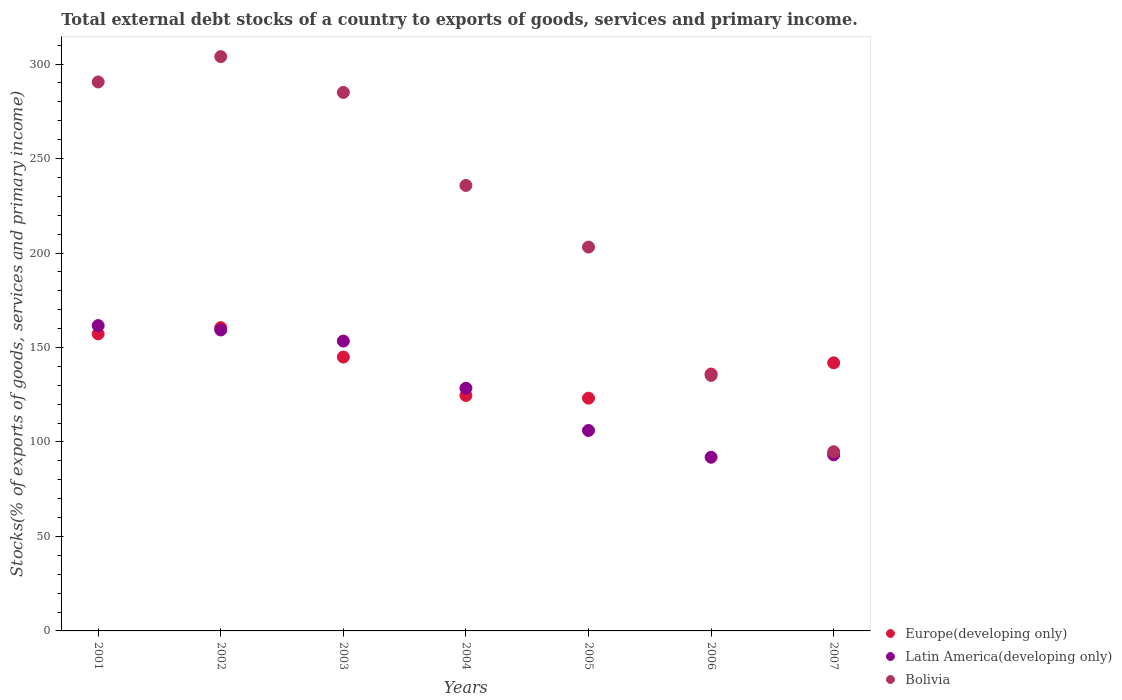Is the number of dotlines equal to the number of legend labels?
Give a very brief answer. Yes. What is the total debt stocks in Latin America(developing only) in 2001?
Provide a short and direct response. 161.59. Across all years, what is the maximum total debt stocks in Latin America(developing only)?
Offer a terse response. 161.59. Across all years, what is the minimum total debt stocks in Europe(developing only)?
Your response must be concise. 123.19. What is the total total debt stocks in Latin America(developing only) in the graph?
Provide a short and direct response. 893.89. What is the difference between the total debt stocks in Latin America(developing only) in 2004 and that in 2006?
Your response must be concise. 36.52. What is the difference between the total debt stocks in Latin America(developing only) in 2003 and the total debt stocks in Europe(developing only) in 2001?
Your answer should be very brief. -3.82. What is the average total debt stocks in Latin America(developing only) per year?
Provide a succinct answer. 127.7. In the year 2004, what is the difference between the total debt stocks in Bolivia and total debt stocks in Latin America(developing only)?
Provide a short and direct response. 107.32. What is the ratio of the total debt stocks in Europe(developing only) in 2005 to that in 2006?
Offer a very short reply. 0.91. Is the difference between the total debt stocks in Bolivia in 2003 and 2007 greater than the difference between the total debt stocks in Latin America(developing only) in 2003 and 2007?
Ensure brevity in your answer.  Yes. What is the difference between the highest and the second highest total debt stocks in Europe(developing only)?
Make the answer very short. 3.29. What is the difference between the highest and the lowest total debt stocks in Latin America(developing only)?
Offer a terse response. 69.67. Is it the case that in every year, the sum of the total debt stocks in Bolivia and total debt stocks in Latin America(developing only)  is greater than the total debt stocks in Europe(developing only)?
Keep it short and to the point. Yes. Is the total debt stocks in Bolivia strictly less than the total debt stocks in Latin America(developing only) over the years?
Provide a succinct answer. No. How many dotlines are there?
Provide a succinct answer. 3. How many years are there in the graph?
Ensure brevity in your answer.  7. Are the values on the major ticks of Y-axis written in scientific E-notation?
Offer a terse response. No. Does the graph contain any zero values?
Your response must be concise. No. What is the title of the graph?
Offer a terse response. Total external debt stocks of a country to exports of goods, services and primary income. What is the label or title of the Y-axis?
Your answer should be compact. Stocks(% of exports of goods, services and primary income). What is the Stocks(% of exports of goods, services and primary income) in Europe(developing only) in 2001?
Provide a short and direct response. 157.22. What is the Stocks(% of exports of goods, services and primary income) of Latin America(developing only) in 2001?
Provide a short and direct response. 161.59. What is the Stocks(% of exports of goods, services and primary income) in Bolivia in 2001?
Offer a terse response. 290.53. What is the Stocks(% of exports of goods, services and primary income) in Europe(developing only) in 2002?
Your answer should be very brief. 160.51. What is the Stocks(% of exports of goods, services and primary income) of Latin America(developing only) in 2002?
Keep it short and to the point. 159.27. What is the Stocks(% of exports of goods, services and primary income) of Bolivia in 2002?
Ensure brevity in your answer.  303.95. What is the Stocks(% of exports of goods, services and primary income) in Europe(developing only) in 2003?
Your answer should be very brief. 144.95. What is the Stocks(% of exports of goods, services and primary income) of Latin America(developing only) in 2003?
Offer a very short reply. 153.4. What is the Stocks(% of exports of goods, services and primary income) in Bolivia in 2003?
Your answer should be very brief. 284.99. What is the Stocks(% of exports of goods, services and primary income) of Europe(developing only) in 2004?
Give a very brief answer. 124.59. What is the Stocks(% of exports of goods, services and primary income) of Latin America(developing only) in 2004?
Make the answer very short. 128.44. What is the Stocks(% of exports of goods, services and primary income) of Bolivia in 2004?
Keep it short and to the point. 235.76. What is the Stocks(% of exports of goods, services and primary income) in Europe(developing only) in 2005?
Your answer should be very brief. 123.19. What is the Stocks(% of exports of goods, services and primary income) in Latin America(developing only) in 2005?
Give a very brief answer. 106.09. What is the Stocks(% of exports of goods, services and primary income) of Bolivia in 2005?
Keep it short and to the point. 203.15. What is the Stocks(% of exports of goods, services and primary income) of Europe(developing only) in 2006?
Make the answer very short. 135.96. What is the Stocks(% of exports of goods, services and primary income) in Latin America(developing only) in 2006?
Offer a very short reply. 91.92. What is the Stocks(% of exports of goods, services and primary income) of Bolivia in 2006?
Make the answer very short. 135.23. What is the Stocks(% of exports of goods, services and primary income) of Europe(developing only) in 2007?
Offer a very short reply. 141.88. What is the Stocks(% of exports of goods, services and primary income) of Latin America(developing only) in 2007?
Offer a terse response. 93.18. What is the Stocks(% of exports of goods, services and primary income) in Bolivia in 2007?
Provide a short and direct response. 94.83. Across all years, what is the maximum Stocks(% of exports of goods, services and primary income) in Europe(developing only)?
Keep it short and to the point. 160.51. Across all years, what is the maximum Stocks(% of exports of goods, services and primary income) in Latin America(developing only)?
Offer a very short reply. 161.59. Across all years, what is the maximum Stocks(% of exports of goods, services and primary income) of Bolivia?
Provide a short and direct response. 303.95. Across all years, what is the minimum Stocks(% of exports of goods, services and primary income) in Europe(developing only)?
Provide a succinct answer. 123.19. Across all years, what is the minimum Stocks(% of exports of goods, services and primary income) of Latin America(developing only)?
Ensure brevity in your answer.  91.92. Across all years, what is the minimum Stocks(% of exports of goods, services and primary income) in Bolivia?
Make the answer very short. 94.83. What is the total Stocks(% of exports of goods, services and primary income) in Europe(developing only) in the graph?
Keep it short and to the point. 988.29. What is the total Stocks(% of exports of goods, services and primary income) of Latin America(developing only) in the graph?
Your response must be concise. 893.89. What is the total Stocks(% of exports of goods, services and primary income) of Bolivia in the graph?
Your response must be concise. 1548.45. What is the difference between the Stocks(% of exports of goods, services and primary income) of Europe(developing only) in 2001 and that in 2002?
Ensure brevity in your answer.  -3.29. What is the difference between the Stocks(% of exports of goods, services and primary income) of Latin America(developing only) in 2001 and that in 2002?
Your response must be concise. 2.32. What is the difference between the Stocks(% of exports of goods, services and primary income) of Bolivia in 2001 and that in 2002?
Ensure brevity in your answer.  -13.42. What is the difference between the Stocks(% of exports of goods, services and primary income) in Europe(developing only) in 2001 and that in 2003?
Provide a short and direct response. 12.27. What is the difference between the Stocks(% of exports of goods, services and primary income) in Latin America(developing only) in 2001 and that in 2003?
Make the answer very short. 8.2. What is the difference between the Stocks(% of exports of goods, services and primary income) of Bolivia in 2001 and that in 2003?
Ensure brevity in your answer.  5.54. What is the difference between the Stocks(% of exports of goods, services and primary income) of Europe(developing only) in 2001 and that in 2004?
Your response must be concise. 32.63. What is the difference between the Stocks(% of exports of goods, services and primary income) of Latin America(developing only) in 2001 and that in 2004?
Offer a terse response. 33.15. What is the difference between the Stocks(% of exports of goods, services and primary income) of Bolivia in 2001 and that in 2004?
Provide a succinct answer. 54.77. What is the difference between the Stocks(% of exports of goods, services and primary income) of Europe(developing only) in 2001 and that in 2005?
Give a very brief answer. 34.03. What is the difference between the Stocks(% of exports of goods, services and primary income) in Latin America(developing only) in 2001 and that in 2005?
Your answer should be very brief. 55.5. What is the difference between the Stocks(% of exports of goods, services and primary income) of Bolivia in 2001 and that in 2005?
Your answer should be compact. 87.38. What is the difference between the Stocks(% of exports of goods, services and primary income) of Europe(developing only) in 2001 and that in 2006?
Provide a succinct answer. 21.26. What is the difference between the Stocks(% of exports of goods, services and primary income) of Latin America(developing only) in 2001 and that in 2006?
Offer a very short reply. 69.67. What is the difference between the Stocks(% of exports of goods, services and primary income) of Bolivia in 2001 and that in 2006?
Ensure brevity in your answer.  155.3. What is the difference between the Stocks(% of exports of goods, services and primary income) of Europe(developing only) in 2001 and that in 2007?
Give a very brief answer. 15.34. What is the difference between the Stocks(% of exports of goods, services and primary income) in Latin America(developing only) in 2001 and that in 2007?
Provide a succinct answer. 68.41. What is the difference between the Stocks(% of exports of goods, services and primary income) of Bolivia in 2001 and that in 2007?
Offer a terse response. 195.7. What is the difference between the Stocks(% of exports of goods, services and primary income) of Europe(developing only) in 2002 and that in 2003?
Provide a short and direct response. 15.55. What is the difference between the Stocks(% of exports of goods, services and primary income) in Latin America(developing only) in 2002 and that in 2003?
Your answer should be very brief. 5.87. What is the difference between the Stocks(% of exports of goods, services and primary income) in Bolivia in 2002 and that in 2003?
Your answer should be very brief. 18.95. What is the difference between the Stocks(% of exports of goods, services and primary income) in Europe(developing only) in 2002 and that in 2004?
Ensure brevity in your answer.  35.92. What is the difference between the Stocks(% of exports of goods, services and primary income) of Latin America(developing only) in 2002 and that in 2004?
Provide a succinct answer. 30.83. What is the difference between the Stocks(% of exports of goods, services and primary income) in Bolivia in 2002 and that in 2004?
Give a very brief answer. 68.19. What is the difference between the Stocks(% of exports of goods, services and primary income) in Europe(developing only) in 2002 and that in 2005?
Provide a short and direct response. 37.32. What is the difference between the Stocks(% of exports of goods, services and primary income) in Latin America(developing only) in 2002 and that in 2005?
Ensure brevity in your answer.  53.18. What is the difference between the Stocks(% of exports of goods, services and primary income) in Bolivia in 2002 and that in 2005?
Make the answer very short. 100.8. What is the difference between the Stocks(% of exports of goods, services and primary income) of Europe(developing only) in 2002 and that in 2006?
Provide a short and direct response. 24.55. What is the difference between the Stocks(% of exports of goods, services and primary income) in Latin America(developing only) in 2002 and that in 2006?
Provide a succinct answer. 67.35. What is the difference between the Stocks(% of exports of goods, services and primary income) of Bolivia in 2002 and that in 2006?
Your answer should be compact. 168.71. What is the difference between the Stocks(% of exports of goods, services and primary income) of Europe(developing only) in 2002 and that in 2007?
Provide a short and direct response. 18.62. What is the difference between the Stocks(% of exports of goods, services and primary income) of Latin America(developing only) in 2002 and that in 2007?
Offer a very short reply. 66.09. What is the difference between the Stocks(% of exports of goods, services and primary income) in Bolivia in 2002 and that in 2007?
Your answer should be very brief. 209.12. What is the difference between the Stocks(% of exports of goods, services and primary income) of Europe(developing only) in 2003 and that in 2004?
Your answer should be very brief. 20.36. What is the difference between the Stocks(% of exports of goods, services and primary income) of Latin America(developing only) in 2003 and that in 2004?
Your answer should be very brief. 24.96. What is the difference between the Stocks(% of exports of goods, services and primary income) of Bolivia in 2003 and that in 2004?
Provide a short and direct response. 49.23. What is the difference between the Stocks(% of exports of goods, services and primary income) of Europe(developing only) in 2003 and that in 2005?
Ensure brevity in your answer.  21.76. What is the difference between the Stocks(% of exports of goods, services and primary income) of Latin America(developing only) in 2003 and that in 2005?
Your answer should be compact. 47.31. What is the difference between the Stocks(% of exports of goods, services and primary income) in Bolivia in 2003 and that in 2005?
Ensure brevity in your answer.  81.84. What is the difference between the Stocks(% of exports of goods, services and primary income) in Europe(developing only) in 2003 and that in 2006?
Ensure brevity in your answer.  9. What is the difference between the Stocks(% of exports of goods, services and primary income) in Latin America(developing only) in 2003 and that in 2006?
Make the answer very short. 61.48. What is the difference between the Stocks(% of exports of goods, services and primary income) of Bolivia in 2003 and that in 2006?
Offer a very short reply. 149.76. What is the difference between the Stocks(% of exports of goods, services and primary income) in Europe(developing only) in 2003 and that in 2007?
Your answer should be very brief. 3.07. What is the difference between the Stocks(% of exports of goods, services and primary income) in Latin America(developing only) in 2003 and that in 2007?
Offer a terse response. 60.22. What is the difference between the Stocks(% of exports of goods, services and primary income) in Bolivia in 2003 and that in 2007?
Make the answer very short. 190.16. What is the difference between the Stocks(% of exports of goods, services and primary income) of Europe(developing only) in 2004 and that in 2005?
Offer a very short reply. 1.4. What is the difference between the Stocks(% of exports of goods, services and primary income) of Latin America(developing only) in 2004 and that in 2005?
Offer a very short reply. 22.35. What is the difference between the Stocks(% of exports of goods, services and primary income) of Bolivia in 2004 and that in 2005?
Keep it short and to the point. 32.61. What is the difference between the Stocks(% of exports of goods, services and primary income) of Europe(developing only) in 2004 and that in 2006?
Provide a short and direct response. -11.37. What is the difference between the Stocks(% of exports of goods, services and primary income) in Latin America(developing only) in 2004 and that in 2006?
Give a very brief answer. 36.52. What is the difference between the Stocks(% of exports of goods, services and primary income) in Bolivia in 2004 and that in 2006?
Your answer should be compact. 100.52. What is the difference between the Stocks(% of exports of goods, services and primary income) of Europe(developing only) in 2004 and that in 2007?
Ensure brevity in your answer.  -17.29. What is the difference between the Stocks(% of exports of goods, services and primary income) of Latin America(developing only) in 2004 and that in 2007?
Provide a short and direct response. 35.26. What is the difference between the Stocks(% of exports of goods, services and primary income) in Bolivia in 2004 and that in 2007?
Keep it short and to the point. 140.93. What is the difference between the Stocks(% of exports of goods, services and primary income) in Europe(developing only) in 2005 and that in 2006?
Ensure brevity in your answer.  -12.77. What is the difference between the Stocks(% of exports of goods, services and primary income) of Latin America(developing only) in 2005 and that in 2006?
Your response must be concise. 14.17. What is the difference between the Stocks(% of exports of goods, services and primary income) in Bolivia in 2005 and that in 2006?
Offer a very short reply. 67.92. What is the difference between the Stocks(% of exports of goods, services and primary income) of Europe(developing only) in 2005 and that in 2007?
Keep it short and to the point. -18.7. What is the difference between the Stocks(% of exports of goods, services and primary income) in Latin America(developing only) in 2005 and that in 2007?
Give a very brief answer. 12.91. What is the difference between the Stocks(% of exports of goods, services and primary income) in Bolivia in 2005 and that in 2007?
Provide a short and direct response. 108.32. What is the difference between the Stocks(% of exports of goods, services and primary income) of Europe(developing only) in 2006 and that in 2007?
Offer a terse response. -5.93. What is the difference between the Stocks(% of exports of goods, services and primary income) in Latin America(developing only) in 2006 and that in 2007?
Ensure brevity in your answer.  -1.26. What is the difference between the Stocks(% of exports of goods, services and primary income) of Bolivia in 2006 and that in 2007?
Offer a terse response. 40.4. What is the difference between the Stocks(% of exports of goods, services and primary income) in Europe(developing only) in 2001 and the Stocks(% of exports of goods, services and primary income) in Latin America(developing only) in 2002?
Give a very brief answer. -2.05. What is the difference between the Stocks(% of exports of goods, services and primary income) in Europe(developing only) in 2001 and the Stocks(% of exports of goods, services and primary income) in Bolivia in 2002?
Provide a succinct answer. -146.73. What is the difference between the Stocks(% of exports of goods, services and primary income) of Latin America(developing only) in 2001 and the Stocks(% of exports of goods, services and primary income) of Bolivia in 2002?
Ensure brevity in your answer.  -142.35. What is the difference between the Stocks(% of exports of goods, services and primary income) in Europe(developing only) in 2001 and the Stocks(% of exports of goods, services and primary income) in Latin America(developing only) in 2003?
Give a very brief answer. 3.82. What is the difference between the Stocks(% of exports of goods, services and primary income) of Europe(developing only) in 2001 and the Stocks(% of exports of goods, services and primary income) of Bolivia in 2003?
Your response must be concise. -127.78. What is the difference between the Stocks(% of exports of goods, services and primary income) of Latin America(developing only) in 2001 and the Stocks(% of exports of goods, services and primary income) of Bolivia in 2003?
Provide a succinct answer. -123.4. What is the difference between the Stocks(% of exports of goods, services and primary income) in Europe(developing only) in 2001 and the Stocks(% of exports of goods, services and primary income) in Latin America(developing only) in 2004?
Offer a terse response. 28.78. What is the difference between the Stocks(% of exports of goods, services and primary income) in Europe(developing only) in 2001 and the Stocks(% of exports of goods, services and primary income) in Bolivia in 2004?
Your answer should be compact. -78.54. What is the difference between the Stocks(% of exports of goods, services and primary income) of Latin America(developing only) in 2001 and the Stocks(% of exports of goods, services and primary income) of Bolivia in 2004?
Give a very brief answer. -74.17. What is the difference between the Stocks(% of exports of goods, services and primary income) in Europe(developing only) in 2001 and the Stocks(% of exports of goods, services and primary income) in Latin America(developing only) in 2005?
Keep it short and to the point. 51.13. What is the difference between the Stocks(% of exports of goods, services and primary income) in Europe(developing only) in 2001 and the Stocks(% of exports of goods, services and primary income) in Bolivia in 2005?
Ensure brevity in your answer.  -45.93. What is the difference between the Stocks(% of exports of goods, services and primary income) in Latin America(developing only) in 2001 and the Stocks(% of exports of goods, services and primary income) in Bolivia in 2005?
Provide a succinct answer. -41.56. What is the difference between the Stocks(% of exports of goods, services and primary income) of Europe(developing only) in 2001 and the Stocks(% of exports of goods, services and primary income) of Latin America(developing only) in 2006?
Your answer should be very brief. 65.3. What is the difference between the Stocks(% of exports of goods, services and primary income) in Europe(developing only) in 2001 and the Stocks(% of exports of goods, services and primary income) in Bolivia in 2006?
Provide a succinct answer. 21.98. What is the difference between the Stocks(% of exports of goods, services and primary income) of Latin America(developing only) in 2001 and the Stocks(% of exports of goods, services and primary income) of Bolivia in 2006?
Ensure brevity in your answer.  26.36. What is the difference between the Stocks(% of exports of goods, services and primary income) of Europe(developing only) in 2001 and the Stocks(% of exports of goods, services and primary income) of Latin America(developing only) in 2007?
Provide a succinct answer. 64.04. What is the difference between the Stocks(% of exports of goods, services and primary income) in Europe(developing only) in 2001 and the Stocks(% of exports of goods, services and primary income) in Bolivia in 2007?
Offer a terse response. 62.39. What is the difference between the Stocks(% of exports of goods, services and primary income) in Latin America(developing only) in 2001 and the Stocks(% of exports of goods, services and primary income) in Bolivia in 2007?
Your answer should be compact. 66.76. What is the difference between the Stocks(% of exports of goods, services and primary income) in Europe(developing only) in 2002 and the Stocks(% of exports of goods, services and primary income) in Latin America(developing only) in 2003?
Keep it short and to the point. 7.11. What is the difference between the Stocks(% of exports of goods, services and primary income) in Europe(developing only) in 2002 and the Stocks(% of exports of goods, services and primary income) in Bolivia in 2003?
Ensure brevity in your answer.  -124.49. What is the difference between the Stocks(% of exports of goods, services and primary income) in Latin America(developing only) in 2002 and the Stocks(% of exports of goods, services and primary income) in Bolivia in 2003?
Your answer should be compact. -125.72. What is the difference between the Stocks(% of exports of goods, services and primary income) in Europe(developing only) in 2002 and the Stocks(% of exports of goods, services and primary income) in Latin America(developing only) in 2004?
Give a very brief answer. 32.06. What is the difference between the Stocks(% of exports of goods, services and primary income) in Europe(developing only) in 2002 and the Stocks(% of exports of goods, services and primary income) in Bolivia in 2004?
Your answer should be very brief. -75.25. What is the difference between the Stocks(% of exports of goods, services and primary income) in Latin America(developing only) in 2002 and the Stocks(% of exports of goods, services and primary income) in Bolivia in 2004?
Keep it short and to the point. -76.49. What is the difference between the Stocks(% of exports of goods, services and primary income) of Europe(developing only) in 2002 and the Stocks(% of exports of goods, services and primary income) of Latin America(developing only) in 2005?
Offer a very short reply. 54.42. What is the difference between the Stocks(% of exports of goods, services and primary income) of Europe(developing only) in 2002 and the Stocks(% of exports of goods, services and primary income) of Bolivia in 2005?
Offer a very short reply. -42.64. What is the difference between the Stocks(% of exports of goods, services and primary income) of Latin America(developing only) in 2002 and the Stocks(% of exports of goods, services and primary income) of Bolivia in 2005?
Make the answer very short. -43.88. What is the difference between the Stocks(% of exports of goods, services and primary income) in Europe(developing only) in 2002 and the Stocks(% of exports of goods, services and primary income) in Latin America(developing only) in 2006?
Keep it short and to the point. 68.59. What is the difference between the Stocks(% of exports of goods, services and primary income) of Europe(developing only) in 2002 and the Stocks(% of exports of goods, services and primary income) of Bolivia in 2006?
Give a very brief answer. 25.27. What is the difference between the Stocks(% of exports of goods, services and primary income) of Latin America(developing only) in 2002 and the Stocks(% of exports of goods, services and primary income) of Bolivia in 2006?
Your answer should be very brief. 24.04. What is the difference between the Stocks(% of exports of goods, services and primary income) in Europe(developing only) in 2002 and the Stocks(% of exports of goods, services and primary income) in Latin America(developing only) in 2007?
Offer a very short reply. 67.33. What is the difference between the Stocks(% of exports of goods, services and primary income) of Europe(developing only) in 2002 and the Stocks(% of exports of goods, services and primary income) of Bolivia in 2007?
Offer a very short reply. 65.67. What is the difference between the Stocks(% of exports of goods, services and primary income) in Latin America(developing only) in 2002 and the Stocks(% of exports of goods, services and primary income) in Bolivia in 2007?
Provide a succinct answer. 64.44. What is the difference between the Stocks(% of exports of goods, services and primary income) of Europe(developing only) in 2003 and the Stocks(% of exports of goods, services and primary income) of Latin America(developing only) in 2004?
Offer a very short reply. 16.51. What is the difference between the Stocks(% of exports of goods, services and primary income) of Europe(developing only) in 2003 and the Stocks(% of exports of goods, services and primary income) of Bolivia in 2004?
Offer a very short reply. -90.81. What is the difference between the Stocks(% of exports of goods, services and primary income) in Latin America(developing only) in 2003 and the Stocks(% of exports of goods, services and primary income) in Bolivia in 2004?
Ensure brevity in your answer.  -82.36. What is the difference between the Stocks(% of exports of goods, services and primary income) of Europe(developing only) in 2003 and the Stocks(% of exports of goods, services and primary income) of Latin America(developing only) in 2005?
Offer a terse response. 38.86. What is the difference between the Stocks(% of exports of goods, services and primary income) in Europe(developing only) in 2003 and the Stocks(% of exports of goods, services and primary income) in Bolivia in 2005?
Make the answer very short. -58.2. What is the difference between the Stocks(% of exports of goods, services and primary income) of Latin America(developing only) in 2003 and the Stocks(% of exports of goods, services and primary income) of Bolivia in 2005?
Offer a terse response. -49.75. What is the difference between the Stocks(% of exports of goods, services and primary income) of Europe(developing only) in 2003 and the Stocks(% of exports of goods, services and primary income) of Latin America(developing only) in 2006?
Provide a succinct answer. 53.03. What is the difference between the Stocks(% of exports of goods, services and primary income) of Europe(developing only) in 2003 and the Stocks(% of exports of goods, services and primary income) of Bolivia in 2006?
Keep it short and to the point. 9.72. What is the difference between the Stocks(% of exports of goods, services and primary income) in Latin America(developing only) in 2003 and the Stocks(% of exports of goods, services and primary income) in Bolivia in 2006?
Your answer should be compact. 18.16. What is the difference between the Stocks(% of exports of goods, services and primary income) in Europe(developing only) in 2003 and the Stocks(% of exports of goods, services and primary income) in Latin America(developing only) in 2007?
Your answer should be compact. 51.77. What is the difference between the Stocks(% of exports of goods, services and primary income) in Europe(developing only) in 2003 and the Stocks(% of exports of goods, services and primary income) in Bolivia in 2007?
Your answer should be compact. 50.12. What is the difference between the Stocks(% of exports of goods, services and primary income) of Latin America(developing only) in 2003 and the Stocks(% of exports of goods, services and primary income) of Bolivia in 2007?
Provide a short and direct response. 58.56. What is the difference between the Stocks(% of exports of goods, services and primary income) of Europe(developing only) in 2004 and the Stocks(% of exports of goods, services and primary income) of Latin America(developing only) in 2005?
Give a very brief answer. 18.5. What is the difference between the Stocks(% of exports of goods, services and primary income) of Europe(developing only) in 2004 and the Stocks(% of exports of goods, services and primary income) of Bolivia in 2005?
Provide a succinct answer. -78.56. What is the difference between the Stocks(% of exports of goods, services and primary income) of Latin America(developing only) in 2004 and the Stocks(% of exports of goods, services and primary income) of Bolivia in 2005?
Your response must be concise. -74.71. What is the difference between the Stocks(% of exports of goods, services and primary income) of Europe(developing only) in 2004 and the Stocks(% of exports of goods, services and primary income) of Latin America(developing only) in 2006?
Offer a very short reply. 32.67. What is the difference between the Stocks(% of exports of goods, services and primary income) of Europe(developing only) in 2004 and the Stocks(% of exports of goods, services and primary income) of Bolivia in 2006?
Your answer should be very brief. -10.65. What is the difference between the Stocks(% of exports of goods, services and primary income) in Latin America(developing only) in 2004 and the Stocks(% of exports of goods, services and primary income) in Bolivia in 2006?
Your answer should be very brief. -6.79. What is the difference between the Stocks(% of exports of goods, services and primary income) in Europe(developing only) in 2004 and the Stocks(% of exports of goods, services and primary income) in Latin America(developing only) in 2007?
Your answer should be compact. 31.41. What is the difference between the Stocks(% of exports of goods, services and primary income) of Europe(developing only) in 2004 and the Stocks(% of exports of goods, services and primary income) of Bolivia in 2007?
Provide a succinct answer. 29.76. What is the difference between the Stocks(% of exports of goods, services and primary income) in Latin America(developing only) in 2004 and the Stocks(% of exports of goods, services and primary income) in Bolivia in 2007?
Offer a very short reply. 33.61. What is the difference between the Stocks(% of exports of goods, services and primary income) of Europe(developing only) in 2005 and the Stocks(% of exports of goods, services and primary income) of Latin America(developing only) in 2006?
Provide a succinct answer. 31.27. What is the difference between the Stocks(% of exports of goods, services and primary income) in Europe(developing only) in 2005 and the Stocks(% of exports of goods, services and primary income) in Bolivia in 2006?
Offer a terse response. -12.05. What is the difference between the Stocks(% of exports of goods, services and primary income) of Latin America(developing only) in 2005 and the Stocks(% of exports of goods, services and primary income) of Bolivia in 2006?
Your answer should be very brief. -29.14. What is the difference between the Stocks(% of exports of goods, services and primary income) of Europe(developing only) in 2005 and the Stocks(% of exports of goods, services and primary income) of Latin America(developing only) in 2007?
Offer a terse response. 30.01. What is the difference between the Stocks(% of exports of goods, services and primary income) of Europe(developing only) in 2005 and the Stocks(% of exports of goods, services and primary income) of Bolivia in 2007?
Give a very brief answer. 28.35. What is the difference between the Stocks(% of exports of goods, services and primary income) in Latin America(developing only) in 2005 and the Stocks(% of exports of goods, services and primary income) in Bolivia in 2007?
Offer a terse response. 11.26. What is the difference between the Stocks(% of exports of goods, services and primary income) of Europe(developing only) in 2006 and the Stocks(% of exports of goods, services and primary income) of Latin America(developing only) in 2007?
Your answer should be compact. 42.78. What is the difference between the Stocks(% of exports of goods, services and primary income) in Europe(developing only) in 2006 and the Stocks(% of exports of goods, services and primary income) in Bolivia in 2007?
Make the answer very short. 41.12. What is the difference between the Stocks(% of exports of goods, services and primary income) in Latin America(developing only) in 2006 and the Stocks(% of exports of goods, services and primary income) in Bolivia in 2007?
Your answer should be very brief. -2.91. What is the average Stocks(% of exports of goods, services and primary income) of Europe(developing only) per year?
Your answer should be very brief. 141.18. What is the average Stocks(% of exports of goods, services and primary income) of Latin America(developing only) per year?
Your answer should be very brief. 127.7. What is the average Stocks(% of exports of goods, services and primary income) of Bolivia per year?
Provide a succinct answer. 221.21. In the year 2001, what is the difference between the Stocks(% of exports of goods, services and primary income) of Europe(developing only) and Stocks(% of exports of goods, services and primary income) of Latin America(developing only)?
Your answer should be very brief. -4.38. In the year 2001, what is the difference between the Stocks(% of exports of goods, services and primary income) in Europe(developing only) and Stocks(% of exports of goods, services and primary income) in Bolivia?
Provide a short and direct response. -133.31. In the year 2001, what is the difference between the Stocks(% of exports of goods, services and primary income) of Latin America(developing only) and Stocks(% of exports of goods, services and primary income) of Bolivia?
Keep it short and to the point. -128.94. In the year 2002, what is the difference between the Stocks(% of exports of goods, services and primary income) in Europe(developing only) and Stocks(% of exports of goods, services and primary income) in Latin America(developing only)?
Your answer should be compact. 1.24. In the year 2002, what is the difference between the Stocks(% of exports of goods, services and primary income) in Europe(developing only) and Stocks(% of exports of goods, services and primary income) in Bolivia?
Your answer should be compact. -143.44. In the year 2002, what is the difference between the Stocks(% of exports of goods, services and primary income) in Latin America(developing only) and Stocks(% of exports of goods, services and primary income) in Bolivia?
Make the answer very short. -144.68. In the year 2003, what is the difference between the Stocks(% of exports of goods, services and primary income) in Europe(developing only) and Stocks(% of exports of goods, services and primary income) in Latin America(developing only)?
Your answer should be compact. -8.45. In the year 2003, what is the difference between the Stocks(% of exports of goods, services and primary income) of Europe(developing only) and Stocks(% of exports of goods, services and primary income) of Bolivia?
Your answer should be compact. -140.04. In the year 2003, what is the difference between the Stocks(% of exports of goods, services and primary income) in Latin America(developing only) and Stocks(% of exports of goods, services and primary income) in Bolivia?
Make the answer very short. -131.6. In the year 2004, what is the difference between the Stocks(% of exports of goods, services and primary income) in Europe(developing only) and Stocks(% of exports of goods, services and primary income) in Latin America(developing only)?
Give a very brief answer. -3.85. In the year 2004, what is the difference between the Stocks(% of exports of goods, services and primary income) of Europe(developing only) and Stocks(% of exports of goods, services and primary income) of Bolivia?
Keep it short and to the point. -111.17. In the year 2004, what is the difference between the Stocks(% of exports of goods, services and primary income) in Latin America(developing only) and Stocks(% of exports of goods, services and primary income) in Bolivia?
Ensure brevity in your answer.  -107.32. In the year 2005, what is the difference between the Stocks(% of exports of goods, services and primary income) in Europe(developing only) and Stocks(% of exports of goods, services and primary income) in Latin America(developing only)?
Give a very brief answer. 17.1. In the year 2005, what is the difference between the Stocks(% of exports of goods, services and primary income) in Europe(developing only) and Stocks(% of exports of goods, services and primary income) in Bolivia?
Keep it short and to the point. -79.96. In the year 2005, what is the difference between the Stocks(% of exports of goods, services and primary income) in Latin America(developing only) and Stocks(% of exports of goods, services and primary income) in Bolivia?
Your answer should be very brief. -97.06. In the year 2006, what is the difference between the Stocks(% of exports of goods, services and primary income) of Europe(developing only) and Stocks(% of exports of goods, services and primary income) of Latin America(developing only)?
Ensure brevity in your answer.  44.04. In the year 2006, what is the difference between the Stocks(% of exports of goods, services and primary income) in Europe(developing only) and Stocks(% of exports of goods, services and primary income) in Bolivia?
Your answer should be compact. 0.72. In the year 2006, what is the difference between the Stocks(% of exports of goods, services and primary income) in Latin America(developing only) and Stocks(% of exports of goods, services and primary income) in Bolivia?
Keep it short and to the point. -43.31. In the year 2007, what is the difference between the Stocks(% of exports of goods, services and primary income) of Europe(developing only) and Stocks(% of exports of goods, services and primary income) of Latin America(developing only)?
Provide a succinct answer. 48.7. In the year 2007, what is the difference between the Stocks(% of exports of goods, services and primary income) of Europe(developing only) and Stocks(% of exports of goods, services and primary income) of Bolivia?
Ensure brevity in your answer.  47.05. In the year 2007, what is the difference between the Stocks(% of exports of goods, services and primary income) of Latin America(developing only) and Stocks(% of exports of goods, services and primary income) of Bolivia?
Your answer should be compact. -1.65. What is the ratio of the Stocks(% of exports of goods, services and primary income) of Europe(developing only) in 2001 to that in 2002?
Your answer should be very brief. 0.98. What is the ratio of the Stocks(% of exports of goods, services and primary income) in Latin America(developing only) in 2001 to that in 2002?
Provide a succinct answer. 1.01. What is the ratio of the Stocks(% of exports of goods, services and primary income) of Bolivia in 2001 to that in 2002?
Offer a terse response. 0.96. What is the ratio of the Stocks(% of exports of goods, services and primary income) of Europe(developing only) in 2001 to that in 2003?
Provide a succinct answer. 1.08. What is the ratio of the Stocks(% of exports of goods, services and primary income) of Latin America(developing only) in 2001 to that in 2003?
Ensure brevity in your answer.  1.05. What is the ratio of the Stocks(% of exports of goods, services and primary income) in Bolivia in 2001 to that in 2003?
Ensure brevity in your answer.  1.02. What is the ratio of the Stocks(% of exports of goods, services and primary income) of Europe(developing only) in 2001 to that in 2004?
Provide a succinct answer. 1.26. What is the ratio of the Stocks(% of exports of goods, services and primary income) of Latin America(developing only) in 2001 to that in 2004?
Ensure brevity in your answer.  1.26. What is the ratio of the Stocks(% of exports of goods, services and primary income) in Bolivia in 2001 to that in 2004?
Keep it short and to the point. 1.23. What is the ratio of the Stocks(% of exports of goods, services and primary income) of Europe(developing only) in 2001 to that in 2005?
Offer a very short reply. 1.28. What is the ratio of the Stocks(% of exports of goods, services and primary income) of Latin America(developing only) in 2001 to that in 2005?
Provide a short and direct response. 1.52. What is the ratio of the Stocks(% of exports of goods, services and primary income) in Bolivia in 2001 to that in 2005?
Give a very brief answer. 1.43. What is the ratio of the Stocks(% of exports of goods, services and primary income) in Europe(developing only) in 2001 to that in 2006?
Your answer should be very brief. 1.16. What is the ratio of the Stocks(% of exports of goods, services and primary income) of Latin America(developing only) in 2001 to that in 2006?
Offer a terse response. 1.76. What is the ratio of the Stocks(% of exports of goods, services and primary income) in Bolivia in 2001 to that in 2006?
Keep it short and to the point. 2.15. What is the ratio of the Stocks(% of exports of goods, services and primary income) in Europe(developing only) in 2001 to that in 2007?
Your answer should be compact. 1.11. What is the ratio of the Stocks(% of exports of goods, services and primary income) in Latin America(developing only) in 2001 to that in 2007?
Offer a terse response. 1.73. What is the ratio of the Stocks(% of exports of goods, services and primary income) in Bolivia in 2001 to that in 2007?
Your answer should be compact. 3.06. What is the ratio of the Stocks(% of exports of goods, services and primary income) of Europe(developing only) in 2002 to that in 2003?
Your response must be concise. 1.11. What is the ratio of the Stocks(% of exports of goods, services and primary income) of Latin America(developing only) in 2002 to that in 2003?
Your answer should be compact. 1.04. What is the ratio of the Stocks(% of exports of goods, services and primary income) of Bolivia in 2002 to that in 2003?
Provide a succinct answer. 1.07. What is the ratio of the Stocks(% of exports of goods, services and primary income) of Europe(developing only) in 2002 to that in 2004?
Keep it short and to the point. 1.29. What is the ratio of the Stocks(% of exports of goods, services and primary income) of Latin America(developing only) in 2002 to that in 2004?
Provide a short and direct response. 1.24. What is the ratio of the Stocks(% of exports of goods, services and primary income) in Bolivia in 2002 to that in 2004?
Your response must be concise. 1.29. What is the ratio of the Stocks(% of exports of goods, services and primary income) of Europe(developing only) in 2002 to that in 2005?
Provide a short and direct response. 1.3. What is the ratio of the Stocks(% of exports of goods, services and primary income) in Latin America(developing only) in 2002 to that in 2005?
Keep it short and to the point. 1.5. What is the ratio of the Stocks(% of exports of goods, services and primary income) in Bolivia in 2002 to that in 2005?
Provide a succinct answer. 1.5. What is the ratio of the Stocks(% of exports of goods, services and primary income) of Europe(developing only) in 2002 to that in 2006?
Keep it short and to the point. 1.18. What is the ratio of the Stocks(% of exports of goods, services and primary income) in Latin America(developing only) in 2002 to that in 2006?
Your answer should be compact. 1.73. What is the ratio of the Stocks(% of exports of goods, services and primary income) of Bolivia in 2002 to that in 2006?
Offer a very short reply. 2.25. What is the ratio of the Stocks(% of exports of goods, services and primary income) in Europe(developing only) in 2002 to that in 2007?
Provide a succinct answer. 1.13. What is the ratio of the Stocks(% of exports of goods, services and primary income) of Latin America(developing only) in 2002 to that in 2007?
Ensure brevity in your answer.  1.71. What is the ratio of the Stocks(% of exports of goods, services and primary income) in Bolivia in 2002 to that in 2007?
Your response must be concise. 3.21. What is the ratio of the Stocks(% of exports of goods, services and primary income) in Europe(developing only) in 2003 to that in 2004?
Ensure brevity in your answer.  1.16. What is the ratio of the Stocks(% of exports of goods, services and primary income) in Latin America(developing only) in 2003 to that in 2004?
Provide a succinct answer. 1.19. What is the ratio of the Stocks(% of exports of goods, services and primary income) in Bolivia in 2003 to that in 2004?
Your answer should be compact. 1.21. What is the ratio of the Stocks(% of exports of goods, services and primary income) in Europe(developing only) in 2003 to that in 2005?
Make the answer very short. 1.18. What is the ratio of the Stocks(% of exports of goods, services and primary income) in Latin America(developing only) in 2003 to that in 2005?
Ensure brevity in your answer.  1.45. What is the ratio of the Stocks(% of exports of goods, services and primary income) in Bolivia in 2003 to that in 2005?
Ensure brevity in your answer.  1.4. What is the ratio of the Stocks(% of exports of goods, services and primary income) of Europe(developing only) in 2003 to that in 2006?
Offer a very short reply. 1.07. What is the ratio of the Stocks(% of exports of goods, services and primary income) in Latin America(developing only) in 2003 to that in 2006?
Give a very brief answer. 1.67. What is the ratio of the Stocks(% of exports of goods, services and primary income) of Bolivia in 2003 to that in 2006?
Offer a terse response. 2.11. What is the ratio of the Stocks(% of exports of goods, services and primary income) in Europe(developing only) in 2003 to that in 2007?
Provide a succinct answer. 1.02. What is the ratio of the Stocks(% of exports of goods, services and primary income) in Latin America(developing only) in 2003 to that in 2007?
Offer a terse response. 1.65. What is the ratio of the Stocks(% of exports of goods, services and primary income) of Bolivia in 2003 to that in 2007?
Make the answer very short. 3.01. What is the ratio of the Stocks(% of exports of goods, services and primary income) in Europe(developing only) in 2004 to that in 2005?
Provide a short and direct response. 1.01. What is the ratio of the Stocks(% of exports of goods, services and primary income) in Latin America(developing only) in 2004 to that in 2005?
Make the answer very short. 1.21. What is the ratio of the Stocks(% of exports of goods, services and primary income) of Bolivia in 2004 to that in 2005?
Offer a terse response. 1.16. What is the ratio of the Stocks(% of exports of goods, services and primary income) of Europe(developing only) in 2004 to that in 2006?
Make the answer very short. 0.92. What is the ratio of the Stocks(% of exports of goods, services and primary income) in Latin America(developing only) in 2004 to that in 2006?
Ensure brevity in your answer.  1.4. What is the ratio of the Stocks(% of exports of goods, services and primary income) in Bolivia in 2004 to that in 2006?
Your answer should be very brief. 1.74. What is the ratio of the Stocks(% of exports of goods, services and primary income) in Europe(developing only) in 2004 to that in 2007?
Your answer should be compact. 0.88. What is the ratio of the Stocks(% of exports of goods, services and primary income) of Latin America(developing only) in 2004 to that in 2007?
Keep it short and to the point. 1.38. What is the ratio of the Stocks(% of exports of goods, services and primary income) of Bolivia in 2004 to that in 2007?
Make the answer very short. 2.49. What is the ratio of the Stocks(% of exports of goods, services and primary income) in Europe(developing only) in 2005 to that in 2006?
Keep it short and to the point. 0.91. What is the ratio of the Stocks(% of exports of goods, services and primary income) in Latin America(developing only) in 2005 to that in 2006?
Offer a terse response. 1.15. What is the ratio of the Stocks(% of exports of goods, services and primary income) of Bolivia in 2005 to that in 2006?
Offer a terse response. 1.5. What is the ratio of the Stocks(% of exports of goods, services and primary income) in Europe(developing only) in 2005 to that in 2007?
Provide a succinct answer. 0.87. What is the ratio of the Stocks(% of exports of goods, services and primary income) in Latin America(developing only) in 2005 to that in 2007?
Give a very brief answer. 1.14. What is the ratio of the Stocks(% of exports of goods, services and primary income) of Bolivia in 2005 to that in 2007?
Your response must be concise. 2.14. What is the ratio of the Stocks(% of exports of goods, services and primary income) of Europe(developing only) in 2006 to that in 2007?
Your answer should be compact. 0.96. What is the ratio of the Stocks(% of exports of goods, services and primary income) of Latin America(developing only) in 2006 to that in 2007?
Keep it short and to the point. 0.99. What is the ratio of the Stocks(% of exports of goods, services and primary income) of Bolivia in 2006 to that in 2007?
Keep it short and to the point. 1.43. What is the difference between the highest and the second highest Stocks(% of exports of goods, services and primary income) of Europe(developing only)?
Your answer should be very brief. 3.29. What is the difference between the highest and the second highest Stocks(% of exports of goods, services and primary income) in Latin America(developing only)?
Offer a very short reply. 2.32. What is the difference between the highest and the second highest Stocks(% of exports of goods, services and primary income) in Bolivia?
Offer a very short reply. 13.42. What is the difference between the highest and the lowest Stocks(% of exports of goods, services and primary income) in Europe(developing only)?
Your answer should be very brief. 37.32. What is the difference between the highest and the lowest Stocks(% of exports of goods, services and primary income) of Latin America(developing only)?
Your answer should be very brief. 69.67. What is the difference between the highest and the lowest Stocks(% of exports of goods, services and primary income) in Bolivia?
Offer a very short reply. 209.12. 